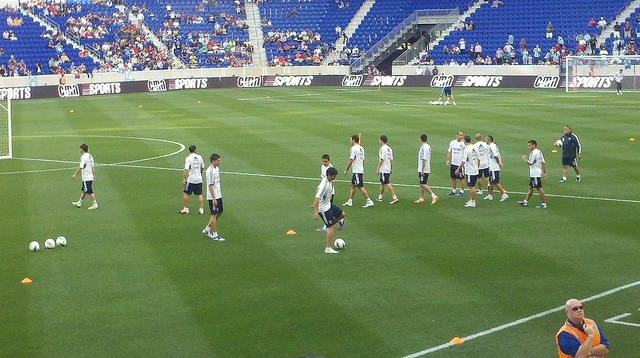Describe the objects in this image and their specific colors. I can see sports ball in white, olive, and gray tones, people in white, gray, navy, and tan tones, people in white, olive, darkgreen, and lightgray tones, people in white, lightgray, tan, black, and gray tones, and people in white, lightgray, black, and olive tones in this image. 